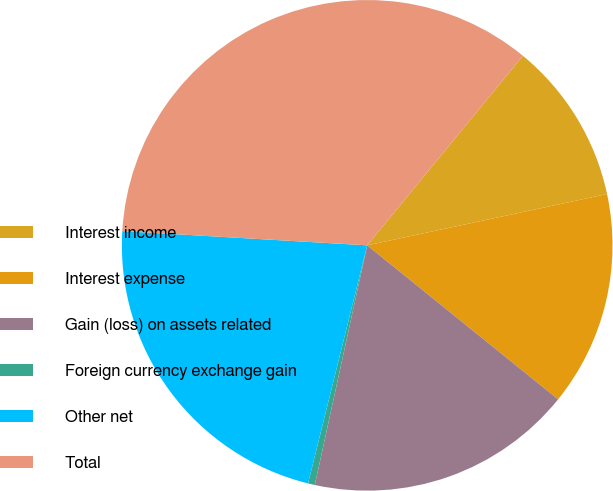<chart> <loc_0><loc_0><loc_500><loc_500><pie_chart><fcel>Interest income<fcel>Interest expense<fcel>Gain (loss) on assets related<fcel>Foreign currency exchange gain<fcel>Other net<fcel>Total<nl><fcel>10.7%<fcel>14.16%<fcel>17.62%<fcel>0.45%<fcel>22.05%<fcel>35.02%<nl></chart> 